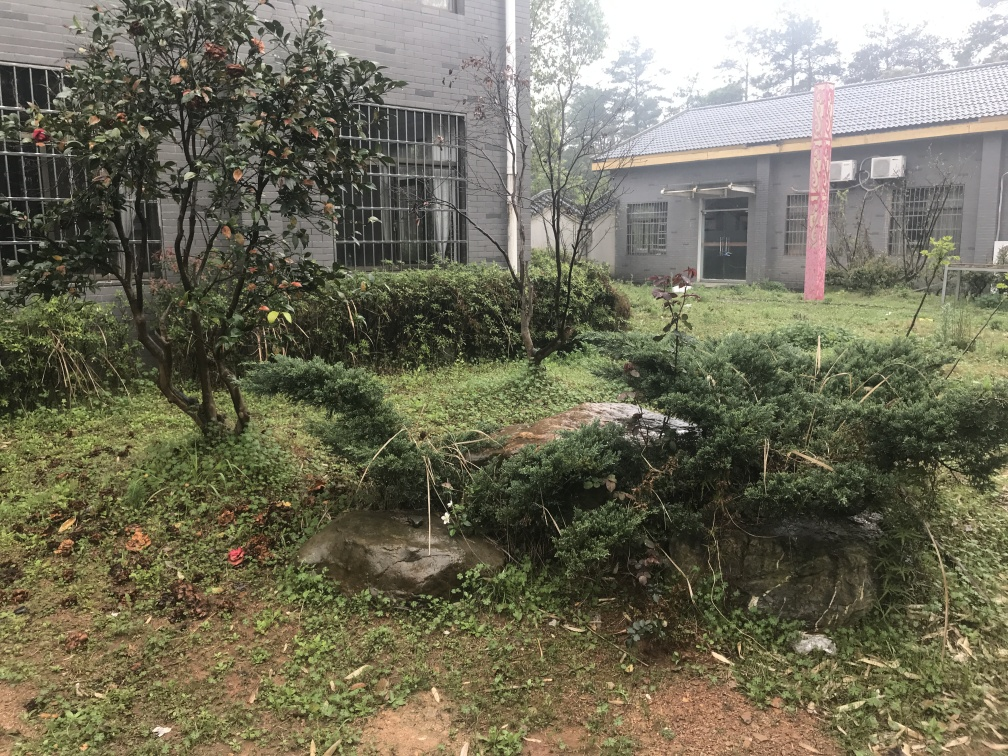What is the quality of this image? The quality of the image is average. It appears to be taken in natural light without professional equipment, resulting in a realistic scene but with a lack of sharpness and optimal composition that would elevate its quality. 